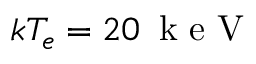<formula> <loc_0><loc_0><loc_500><loc_500>k T _ { e } = 2 0 \, k e V</formula> 